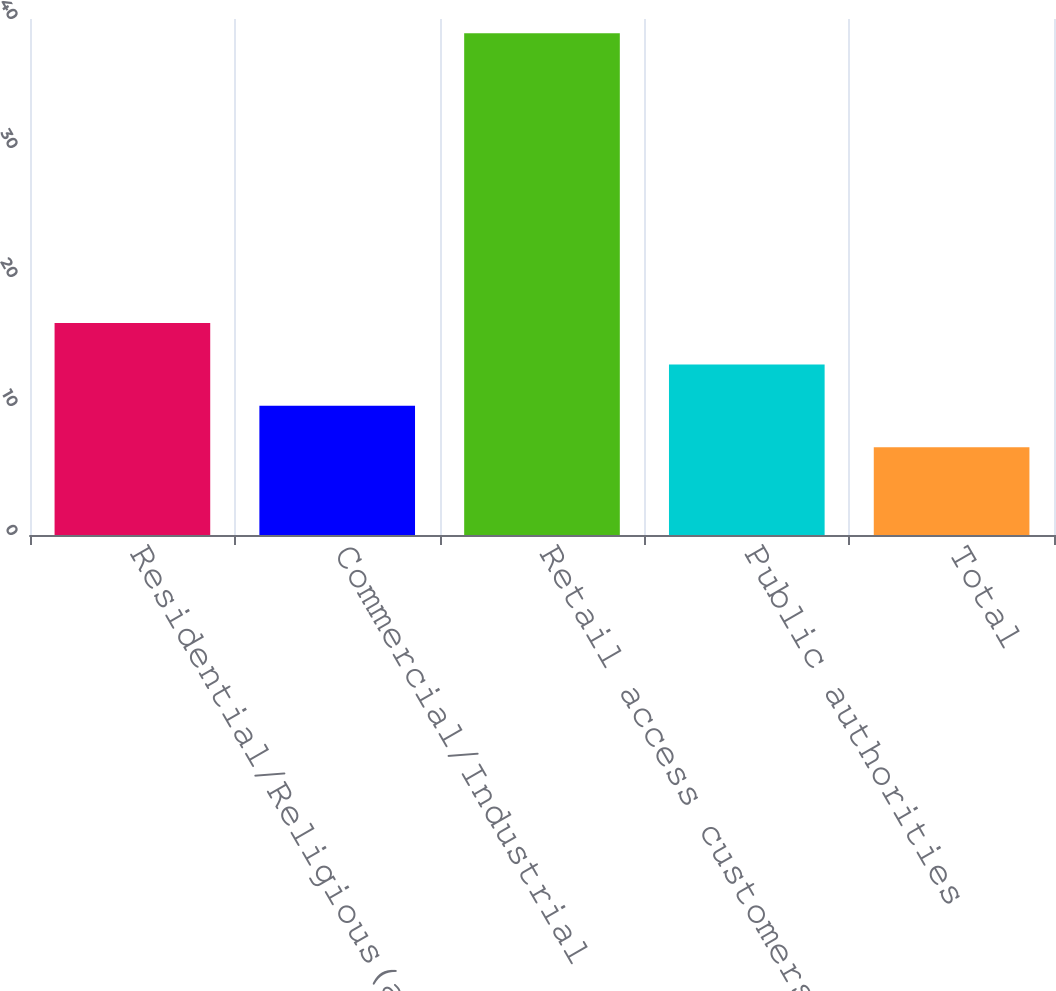<chart> <loc_0><loc_0><loc_500><loc_500><bar_chart><fcel>Residential/Religious(a)<fcel>Commercial/Industrial<fcel>Retail access customers<fcel>Public authorities<fcel>Total<nl><fcel>16.43<fcel>10.01<fcel>38.9<fcel>13.22<fcel>6.8<nl></chart> 